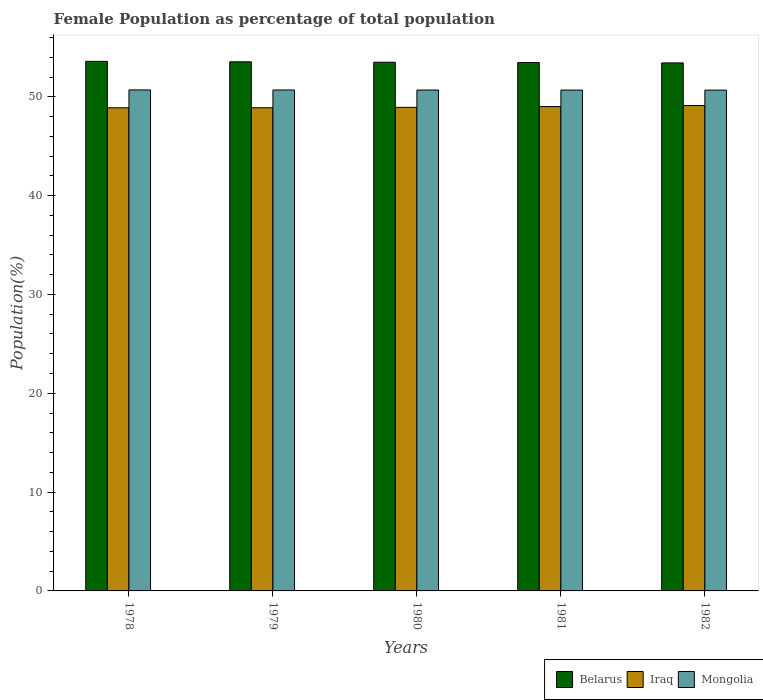Are the number of bars on each tick of the X-axis equal?
Your answer should be compact. Yes. How many bars are there on the 4th tick from the right?
Keep it short and to the point. 3. What is the label of the 5th group of bars from the left?
Give a very brief answer. 1982. In how many cases, is the number of bars for a given year not equal to the number of legend labels?
Provide a succinct answer. 0. What is the female population in in Iraq in 1979?
Your response must be concise. 48.89. Across all years, what is the maximum female population in in Iraq?
Ensure brevity in your answer.  49.12. Across all years, what is the minimum female population in in Mongolia?
Offer a very short reply. 50.68. In which year was the female population in in Iraq minimum?
Your response must be concise. 1978. What is the total female population in in Iraq in the graph?
Offer a terse response. 244.85. What is the difference between the female population in in Mongolia in 1981 and that in 1982?
Provide a short and direct response. 0. What is the difference between the female population in in Belarus in 1981 and the female population in in Iraq in 1982?
Your answer should be very brief. 4.34. What is the average female population in in Mongolia per year?
Keep it short and to the point. 50.69. In the year 1978, what is the difference between the female population in in Belarus and female population in in Iraq?
Offer a terse response. 4.7. In how many years, is the female population in in Belarus greater than 36 %?
Give a very brief answer. 5. What is the ratio of the female population in in Belarus in 1979 to that in 1981?
Your answer should be compact. 1. Is the difference between the female population in in Belarus in 1978 and 1979 greater than the difference between the female population in in Iraq in 1978 and 1979?
Your response must be concise. Yes. What is the difference between the highest and the second highest female population in in Mongolia?
Ensure brevity in your answer.  0. What is the difference between the highest and the lowest female population in in Belarus?
Give a very brief answer. 0.16. What does the 1st bar from the left in 1979 represents?
Ensure brevity in your answer.  Belarus. What does the 2nd bar from the right in 1979 represents?
Your answer should be very brief. Iraq. Are all the bars in the graph horizontal?
Your response must be concise. No. Where does the legend appear in the graph?
Offer a terse response. Bottom right. How many legend labels are there?
Offer a terse response. 3. How are the legend labels stacked?
Ensure brevity in your answer.  Horizontal. What is the title of the graph?
Ensure brevity in your answer.  Female Population as percentage of total population. Does "West Bank and Gaza" appear as one of the legend labels in the graph?
Make the answer very short. No. What is the label or title of the X-axis?
Offer a very short reply. Years. What is the label or title of the Y-axis?
Your answer should be very brief. Population(%). What is the Population(%) in Belarus in 1978?
Give a very brief answer. 53.59. What is the Population(%) of Iraq in 1978?
Offer a very short reply. 48.89. What is the Population(%) in Mongolia in 1978?
Ensure brevity in your answer.  50.7. What is the Population(%) of Belarus in 1979?
Keep it short and to the point. 53.54. What is the Population(%) of Iraq in 1979?
Your answer should be compact. 48.89. What is the Population(%) in Mongolia in 1979?
Give a very brief answer. 50.69. What is the Population(%) of Belarus in 1980?
Offer a very short reply. 53.5. What is the Population(%) of Iraq in 1980?
Make the answer very short. 48.93. What is the Population(%) of Mongolia in 1980?
Provide a succinct answer. 50.69. What is the Population(%) of Belarus in 1981?
Keep it short and to the point. 53.46. What is the Population(%) of Iraq in 1981?
Ensure brevity in your answer.  49.01. What is the Population(%) in Mongolia in 1981?
Make the answer very short. 50.68. What is the Population(%) of Belarus in 1982?
Offer a very short reply. 53.43. What is the Population(%) in Iraq in 1982?
Your answer should be very brief. 49.12. What is the Population(%) in Mongolia in 1982?
Your response must be concise. 50.68. Across all years, what is the maximum Population(%) of Belarus?
Your answer should be compact. 53.59. Across all years, what is the maximum Population(%) in Iraq?
Your answer should be very brief. 49.12. Across all years, what is the maximum Population(%) in Mongolia?
Provide a succinct answer. 50.7. Across all years, what is the minimum Population(%) of Belarus?
Offer a very short reply. 53.43. Across all years, what is the minimum Population(%) in Iraq?
Provide a short and direct response. 48.89. Across all years, what is the minimum Population(%) of Mongolia?
Your response must be concise. 50.68. What is the total Population(%) of Belarus in the graph?
Make the answer very short. 267.52. What is the total Population(%) of Iraq in the graph?
Your response must be concise. 244.85. What is the total Population(%) in Mongolia in the graph?
Provide a short and direct response. 253.43. What is the difference between the Population(%) in Belarus in 1978 and that in 1979?
Your answer should be very brief. 0.05. What is the difference between the Population(%) of Iraq in 1978 and that in 1979?
Your response must be concise. -0. What is the difference between the Population(%) of Mongolia in 1978 and that in 1979?
Ensure brevity in your answer.  0. What is the difference between the Population(%) of Belarus in 1978 and that in 1980?
Give a very brief answer. 0.09. What is the difference between the Population(%) in Iraq in 1978 and that in 1980?
Your response must be concise. -0.04. What is the difference between the Population(%) in Mongolia in 1978 and that in 1980?
Your answer should be very brief. 0.01. What is the difference between the Population(%) in Belarus in 1978 and that in 1981?
Give a very brief answer. 0.12. What is the difference between the Population(%) of Iraq in 1978 and that in 1981?
Your response must be concise. -0.12. What is the difference between the Population(%) of Mongolia in 1978 and that in 1981?
Offer a terse response. 0.01. What is the difference between the Population(%) in Belarus in 1978 and that in 1982?
Provide a short and direct response. 0.16. What is the difference between the Population(%) of Iraq in 1978 and that in 1982?
Offer a terse response. -0.23. What is the difference between the Population(%) in Mongolia in 1978 and that in 1982?
Offer a terse response. 0.02. What is the difference between the Population(%) in Belarus in 1979 and that in 1980?
Your response must be concise. 0.04. What is the difference between the Population(%) in Iraq in 1979 and that in 1980?
Your answer should be compact. -0.04. What is the difference between the Population(%) of Mongolia in 1979 and that in 1980?
Give a very brief answer. 0. What is the difference between the Population(%) in Belarus in 1979 and that in 1981?
Ensure brevity in your answer.  0.08. What is the difference between the Population(%) of Iraq in 1979 and that in 1981?
Provide a short and direct response. -0.12. What is the difference between the Population(%) of Mongolia in 1979 and that in 1981?
Give a very brief answer. 0.01. What is the difference between the Population(%) of Belarus in 1979 and that in 1982?
Your answer should be very brief. 0.11. What is the difference between the Population(%) of Iraq in 1979 and that in 1982?
Your answer should be very brief. -0.23. What is the difference between the Population(%) in Mongolia in 1979 and that in 1982?
Keep it short and to the point. 0.01. What is the difference between the Population(%) in Belarus in 1980 and that in 1981?
Offer a very short reply. 0.04. What is the difference between the Population(%) in Iraq in 1980 and that in 1981?
Provide a short and direct response. -0.08. What is the difference between the Population(%) in Mongolia in 1980 and that in 1981?
Your answer should be compact. 0. What is the difference between the Population(%) in Belarus in 1980 and that in 1982?
Offer a very short reply. 0.07. What is the difference between the Population(%) of Iraq in 1980 and that in 1982?
Keep it short and to the point. -0.19. What is the difference between the Population(%) of Mongolia in 1980 and that in 1982?
Give a very brief answer. 0.01. What is the difference between the Population(%) of Belarus in 1981 and that in 1982?
Ensure brevity in your answer.  0.03. What is the difference between the Population(%) of Iraq in 1981 and that in 1982?
Give a very brief answer. -0.11. What is the difference between the Population(%) of Mongolia in 1981 and that in 1982?
Ensure brevity in your answer.  0. What is the difference between the Population(%) of Belarus in 1978 and the Population(%) of Iraq in 1979?
Keep it short and to the point. 4.7. What is the difference between the Population(%) of Belarus in 1978 and the Population(%) of Mongolia in 1979?
Ensure brevity in your answer.  2.9. What is the difference between the Population(%) in Iraq in 1978 and the Population(%) in Mongolia in 1979?
Provide a succinct answer. -1.8. What is the difference between the Population(%) of Belarus in 1978 and the Population(%) of Iraq in 1980?
Your response must be concise. 4.66. What is the difference between the Population(%) of Belarus in 1978 and the Population(%) of Mongolia in 1980?
Your response must be concise. 2.9. What is the difference between the Population(%) in Iraq in 1978 and the Population(%) in Mongolia in 1980?
Provide a succinct answer. -1.8. What is the difference between the Population(%) in Belarus in 1978 and the Population(%) in Iraq in 1981?
Your answer should be compact. 4.58. What is the difference between the Population(%) of Belarus in 1978 and the Population(%) of Mongolia in 1981?
Offer a very short reply. 2.91. What is the difference between the Population(%) of Iraq in 1978 and the Population(%) of Mongolia in 1981?
Provide a short and direct response. -1.79. What is the difference between the Population(%) in Belarus in 1978 and the Population(%) in Iraq in 1982?
Make the answer very short. 4.47. What is the difference between the Population(%) in Belarus in 1978 and the Population(%) in Mongolia in 1982?
Offer a terse response. 2.91. What is the difference between the Population(%) of Iraq in 1978 and the Population(%) of Mongolia in 1982?
Provide a succinct answer. -1.79. What is the difference between the Population(%) in Belarus in 1979 and the Population(%) in Iraq in 1980?
Your response must be concise. 4.61. What is the difference between the Population(%) in Belarus in 1979 and the Population(%) in Mongolia in 1980?
Provide a short and direct response. 2.86. What is the difference between the Population(%) in Iraq in 1979 and the Population(%) in Mongolia in 1980?
Provide a succinct answer. -1.79. What is the difference between the Population(%) of Belarus in 1979 and the Population(%) of Iraq in 1981?
Keep it short and to the point. 4.53. What is the difference between the Population(%) in Belarus in 1979 and the Population(%) in Mongolia in 1981?
Provide a short and direct response. 2.86. What is the difference between the Population(%) of Iraq in 1979 and the Population(%) of Mongolia in 1981?
Keep it short and to the point. -1.79. What is the difference between the Population(%) in Belarus in 1979 and the Population(%) in Iraq in 1982?
Offer a terse response. 4.42. What is the difference between the Population(%) in Belarus in 1979 and the Population(%) in Mongolia in 1982?
Provide a short and direct response. 2.87. What is the difference between the Population(%) of Iraq in 1979 and the Population(%) of Mongolia in 1982?
Your response must be concise. -1.78. What is the difference between the Population(%) in Belarus in 1980 and the Population(%) in Iraq in 1981?
Offer a terse response. 4.49. What is the difference between the Population(%) of Belarus in 1980 and the Population(%) of Mongolia in 1981?
Make the answer very short. 2.82. What is the difference between the Population(%) in Iraq in 1980 and the Population(%) in Mongolia in 1981?
Your answer should be compact. -1.75. What is the difference between the Population(%) of Belarus in 1980 and the Population(%) of Iraq in 1982?
Keep it short and to the point. 4.38. What is the difference between the Population(%) in Belarus in 1980 and the Population(%) in Mongolia in 1982?
Provide a succinct answer. 2.82. What is the difference between the Population(%) in Iraq in 1980 and the Population(%) in Mongolia in 1982?
Give a very brief answer. -1.74. What is the difference between the Population(%) in Belarus in 1981 and the Population(%) in Iraq in 1982?
Offer a terse response. 4.34. What is the difference between the Population(%) of Belarus in 1981 and the Population(%) of Mongolia in 1982?
Offer a very short reply. 2.79. What is the difference between the Population(%) of Iraq in 1981 and the Population(%) of Mongolia in 1982?
Offer a terse response. -1.67. What is the average Population(%) in Belarus per year?
Give a very brief answer. 53.5. What is the average Population(%) of Iraq per year?
Your response must be concise. 48.97. What is the average Population(%) in Mongolia per year?
Offer a very short reply. 50.69. In the year 1978, what is the difference between the Population(%) in Belarus and Population(%) in Iraq?
Provide a succinct answer. 4.7. In the year 1978, what is the difference between the Population(%) of Belarus and Population(%) of Mongolia?
Offer a terse response. 2.89. In the year 1978, what is the difference between the Population(%) in Iraq and Population(%) in Mongolia?
Your answer should be very brief. -1.81. In the year 1979, what is the difference between the Population(%) in Belarus and Population(%) in Iraq?
Give a very brief answer. 4.65. In the year 1979, what is the difference between the Population(%) in Belarus and Population(%) in Mongolia?
Your response must be concise. 2.85. In the year 1979, what is the difference between the Population(%) in Iraq and Population(%) in Mongolia?
Make the answer very short. -1.8. In the year 1980, what is the difference between the Population(%) in Belarus and Population(%) in Iraq?
Make the answer very short. 4.57. In the year 1980, what is the difference between the Population(%) of Belarus and Population(%) of Mongolia?
Ensure brevity in your answer.  2.81. In the year 1980, what is the difference between the Population(%) in Iraq and Population(%) in Mongolia?
Offer a very short reply. -1.75. In the year 1981, what is the difference between the Population(%) in Belarus and Population(%) in Iraq?
Provide a short and direct response. 4.45. In the year 1981, what is the difference between the Population(%) of Belarus and Population(%) of Mongolia?
Provide a succinct answer. 2.78. In the year 1981, what is the difference between the Population(%) of Iraq and Population(%) of Mongolia?
Your answer should be compact. -1.67. In the year 1982, what is the difference between the Population(%) in Belarus and Population(%) in Iraq?
Give a very brief answer. 4.31. In the year 1982, what is the difference between the Population(%) in Belarus and Population(%) in Mongolia?
Offer a very short reply. 2.75. In the year 1982, what is the difference between the Population(%) of Iraq and Population(%) of Mongolia?
Your answer should be very brief. -1.56. What is the ratio of the Population(%) in Mongolia in 1978 to that in 1979?
Offer a very short reply. 1. What is the ratio of the Population(%) of Mongolia in 1978 to that in 1980?
Ensure brevity in your answer.  1. What is the ratio of the Population(%) of Belarus in 1978 to that in 1981?
Provide a succinct answer. 1. What is the ratio of the Population(%) in Iraq in 1978 to that in 1981?
Give a very brief answer. 1. What is the ratio of the Population(%) of Mongolia in 1978 to that in 1981?
Keep it short and to the point. 1. What is the ratio of the Population(%) in Mongolia in 1979 to that in 1980?
Provide a succinct answer. 1. What is the ratio of the Population(%) of Belarus in 1979 to that in 1981?
Provide a succinct answer. 1. What is the ratio of the Population(%) in Mongolia in 1979 to that in 1981?
Provide a short and direct response. 1. What is the ratio of the Population(%) of Mongolia in 1979 to that in 1982?
Provide a succinct answer. 1. What is the ratio of the Population(%) of Iraq in 1980 to that in 1981?
Provide a short and direct response. 1. What is the ratio of the Population(%) in Belarus in 1980 to that in 1982?
Your answer should be compact. 1. What is the ratio of the Population(%) of Iraq in 1980 to that in 1982?
Your response must be concise. 1. What is the ratio of the Population(%) of Mongolia in 1981 to that in 1982?
Offer a very short reply. 1. What is the difference between the highest and the second highest Population(%) of Belarus?
Offer a very short reply. 0.05. What is the difference between the highest and the second highest Population(%) in Iraq?
Provide a succinct answer. 0.11. What is the difference between the highest and the second highest Population(%) of Mongolia?
Your answer should be very brief. 0. What is the difference between the highest and the lowest Population(%) in Belarus?
Ensure brevity in your answer.  0.16. What is the difference between the highest and the lowest Population(%) in Iraq?
Make the answer very short. 0.23. What is the difference between the highest and the lowest Population(%) in Mongolia?
Your answer should be very brief. 0.02. 